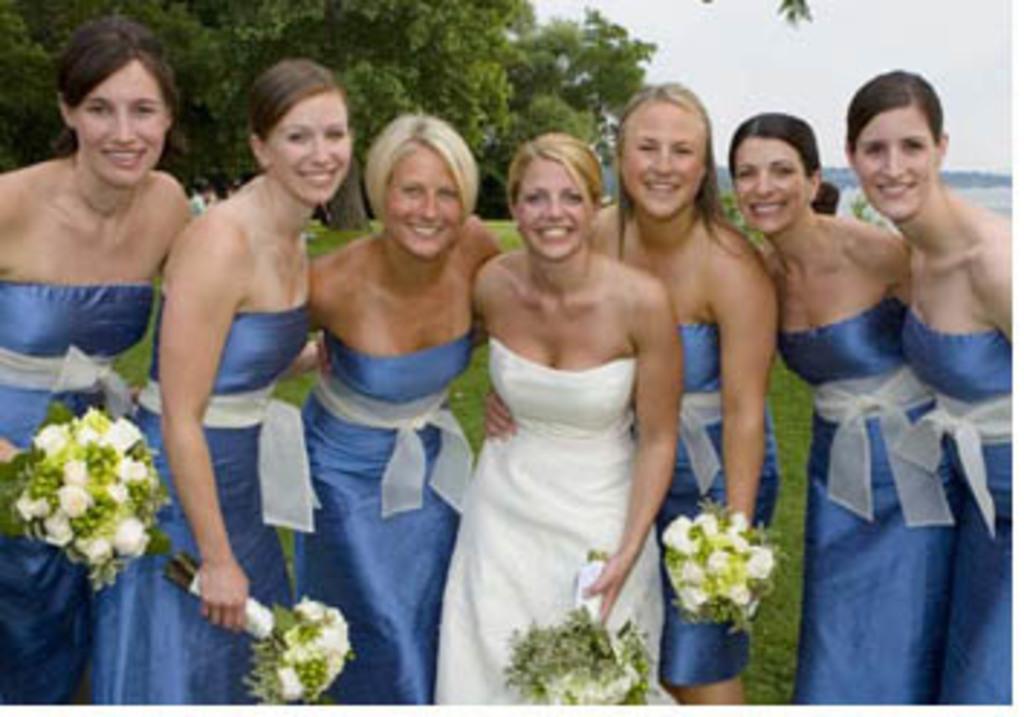Please provide a concise description of this image. Here we can see a group of women. These women are smiling and holding bouquets. Background there is a grass, sky and trees. 